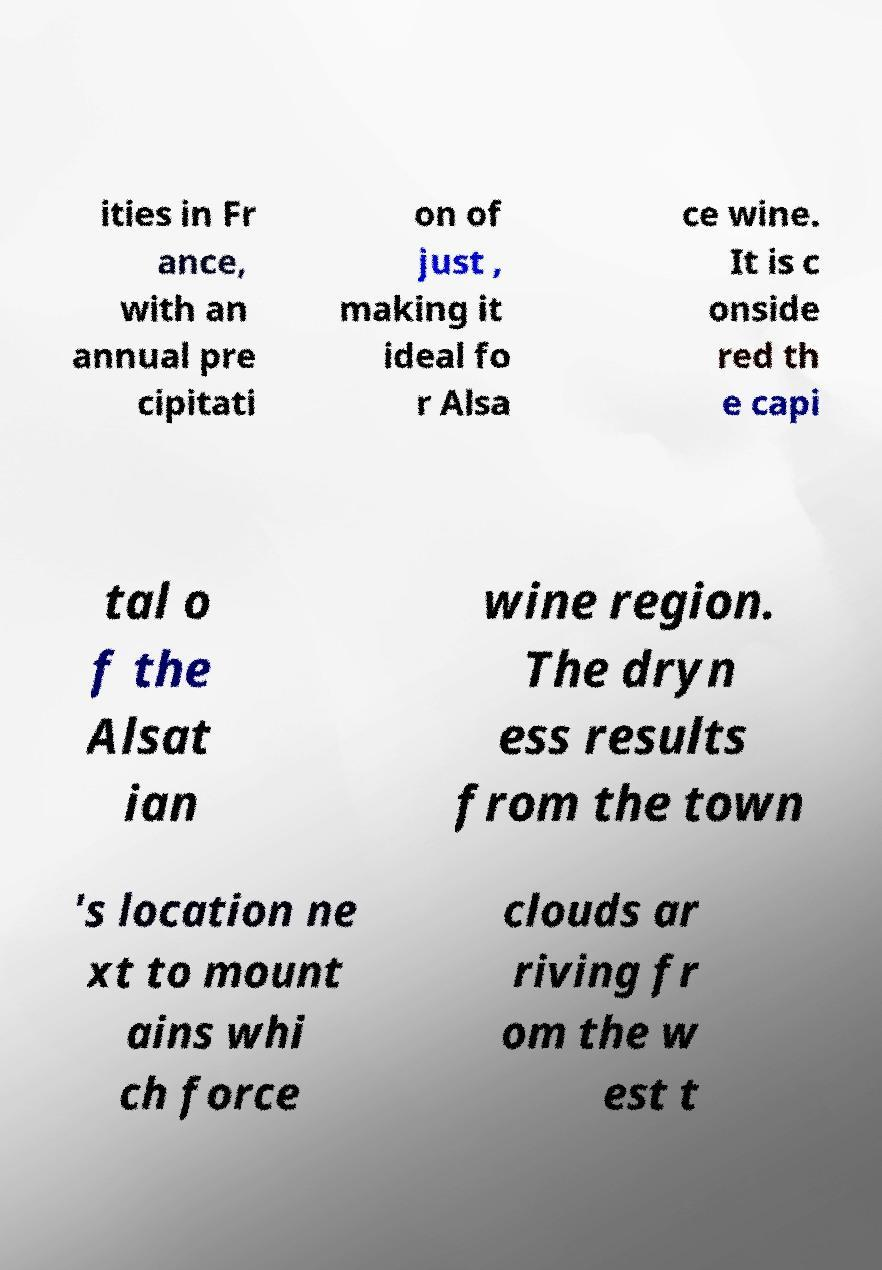For documentation purposes, I need the text within this image transcribed. Could you provide that? ities in Fr ance, with an annual pre cipitati on of just , making it ideal fo r Alsa ce wine. It is c onside red th e capi tal o f the Alsat ian wine region. The dryn ess results from the town 's location ne xt to mount ains whi ch force clouds ar riving fr om the w est t 